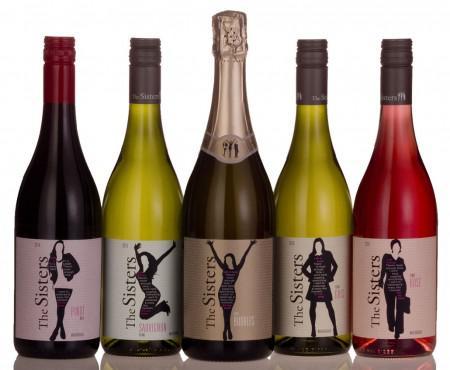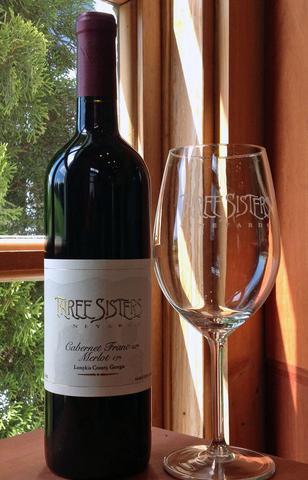The first image is the image on the left, the second image is the image on the right. For the images displayed, is the sentence "Left image shows at least four wine bottles of various colors, arranged in a horizontal row." factually correct? Answer yes or no. Yes. The first image is the image on the left, the second image is the image on the right. Assess this claim about the two images: "There is a row of wine bottles with multiple colors". Correct or not? Answer yes or no. Yes. 